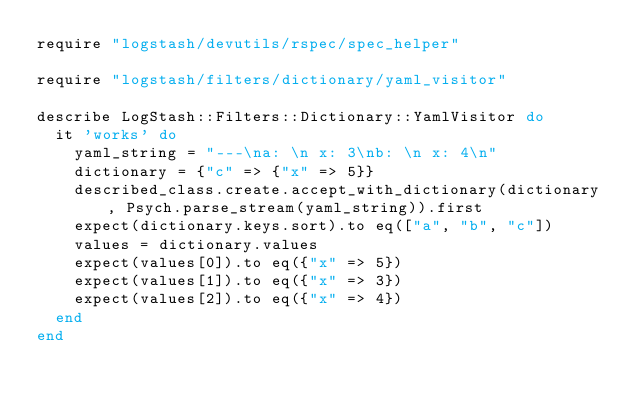<code> <loc_0><loc_0><loc_500><loc_500><_Ruby_>require "logstash/devutils/rspec/spec_helper"

require "logstash/filters/dictionary/yaml_visitor"

describe LogStash::Filters::Dictionary::YamlVisitor do
  it 'works' do
    yaml_string = "---\na: \n x: 3\nb: \n x: 4\n"
    dictionary = {"c" => {"x" => 5}}
    described_class.create.accept_with_dictionary(dictionary, Psych.parse_stream(yaml_string)).first
    expect(dictionary.keys.sort).to eq(["a", "b", "c"])
    values = dictionary.values
    expect(values[0]).to eq({"x" => 5})
    expect(values[1]).to eq({"x" => 3})
    expect(values[2]).to eq({"x" => 4})
  end
end
</code> 